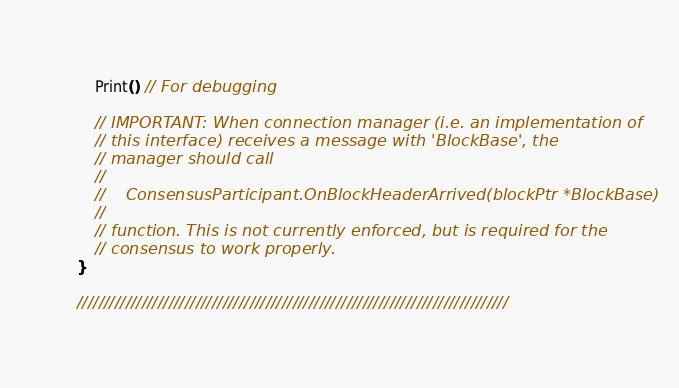Convert code to text. <code><loc_0><loc_0><loc_500><loc_500><_Go_>	Print() // For debugging

	// IMPORTANT: When connection manager (i.e. an implementation of
	// this interface) receives a message with 'BlockBase', the
	// manager should call
	//
	//    ConsensusParticipant.OnBlockHeaderArrived(blockPtr *BlockBase)
	//
	// function. This is not currently enforced, but is required for the
	// consensus to work properly.
}

////////////////////////////////////////////////////////////////////////////////
</code> 